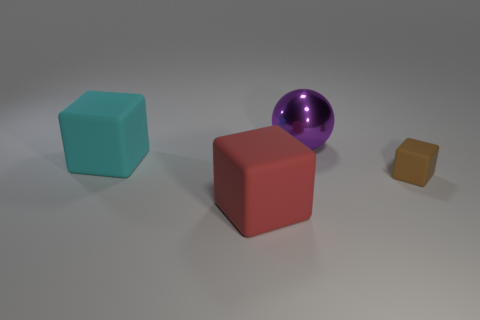Add 4 large metallic objects. How many objects exist? 8 Subtract all balls. How many objects are left? 3 Subtract 0 purple blocks. How many objects are left? 4 Subtract all small matte blocks. Subtract all small brown rubber things. How many objects are left? 2 Add 4 large red matte objects. How many large red matte objects are left? 5 Add 2 big red cubes. How many big red cubes exist? 3 